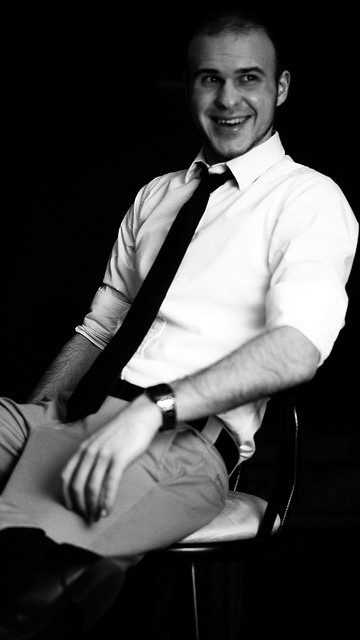Describe the objects in this image and their specific colors. I can see people in black, white, darkgray, and gray tones, chair in black, gray, darkgray, and lightgray tones, and tie in black, gray, and darkgray tones in this image. 